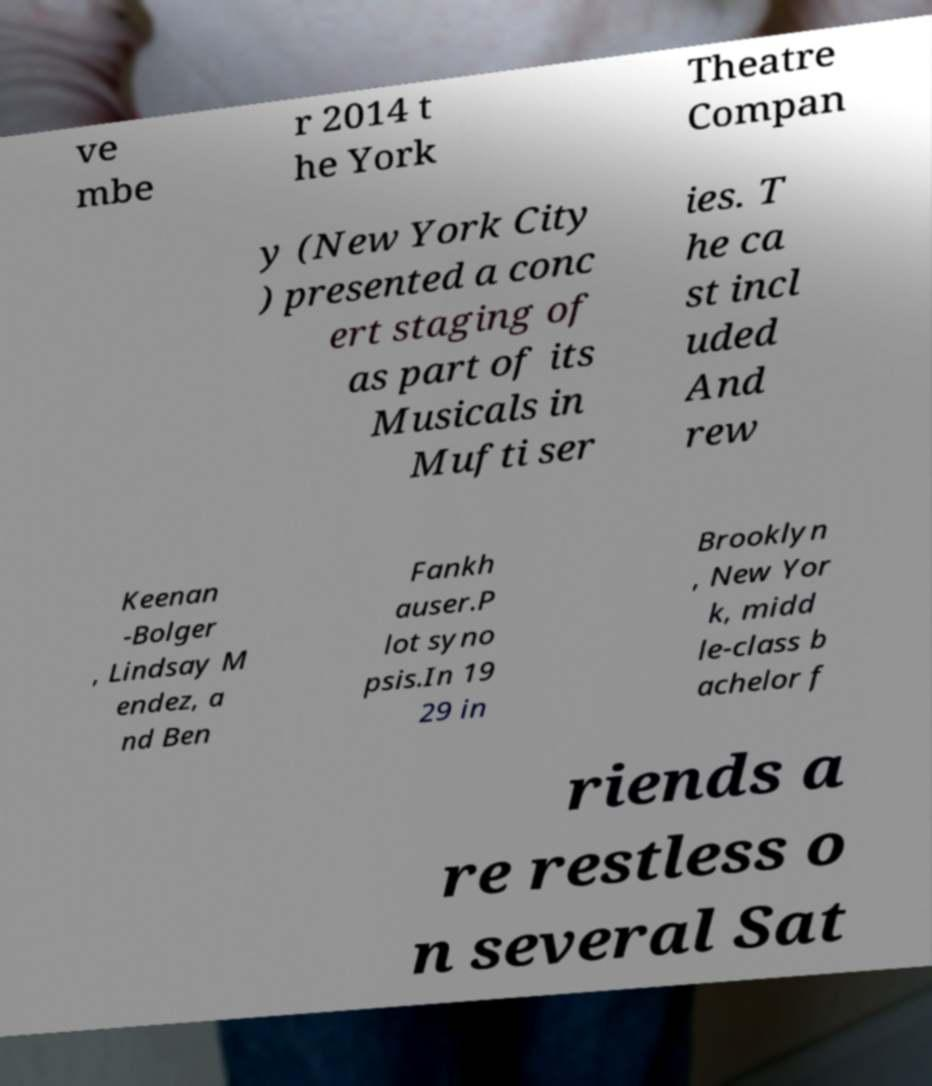Can you accurately transcribe the text from the provided image for me? ve mbe r 2014 t he York Theatre Compan y (New York City ) presented a conc ert staging of as part of its Musicals in Mufti ser ies. T he ca st incl uded And rew Keenan -Bolger , Lindsay M endez, a nd Ben Fankh auser.P lot syno psis.In 19 29 in Brooklyn , New Yor k, midd le-class b achelor f riends a re restless o n several Sat 